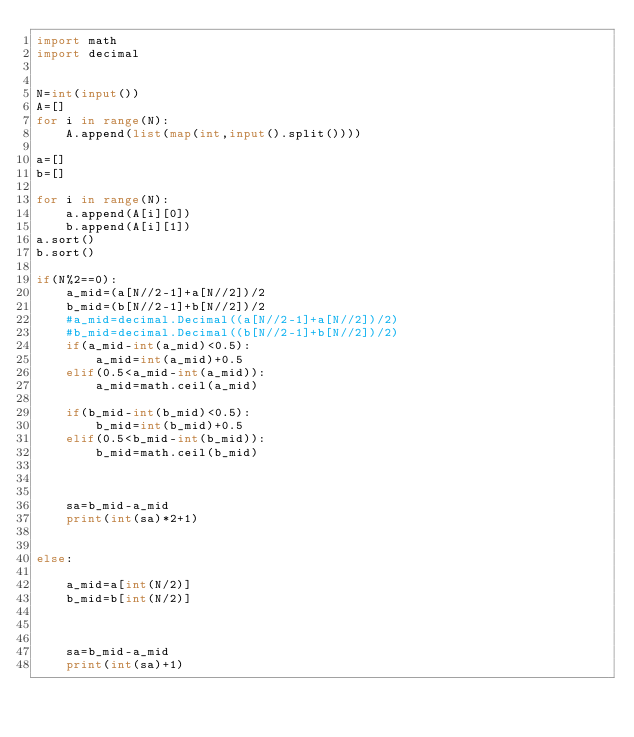Convert code to text. <code><loc_0><loc_0><loc_500><loc_500><_Python_>import math
import decimal


N=int(input())
A=[]
for i in range(N):
    A.append(list(map(int,input().split())))

a=[]
b=[]

for i in range(N):
    a.append(A[i][0])
    b.append(A[i][1])
a.sort()
b.sort()

if(N%2==0):
    a_mid=(a[N//2-1]+a[N//2])/2
    b_mid=(b[N//2-1]+b[N//2])/2
    #a_mid=decimal.Decimal((a[N//2-1]+a[N//2])/2)
    #b_mid=decimal.Decimal((b[N//2-1]+b[N//2])/2)
    if(a_mid-int(a_mid)<0.5):
        a_mid=int(a_mid)+0.5
    elif(0.5<a_mid-int(a_mid)):
        a_mid=math.ceil(a_mid)

    if(b_mid-int(b_mid)<0.5):
        b_mid=int(b_mid)+0.5
    elif(0.5<b_mid-int(b_mid)):
        b_mid=math.ceil(b_mid)



    sa=b_mid-a_mid
    print(int(sa)*2+1)


else:

    a_mid=a[int(N/2)]
    b_mid=b[int(N/2)]



    sa=b_mid-a_mid
    print(int(sa)+1)
</code> 